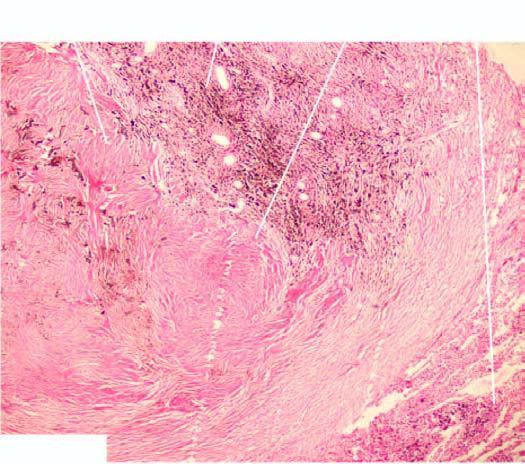re particles at the end of the smear seen surrounding respiratory bronchioles?
Answer the question using a single word or phrase. No 